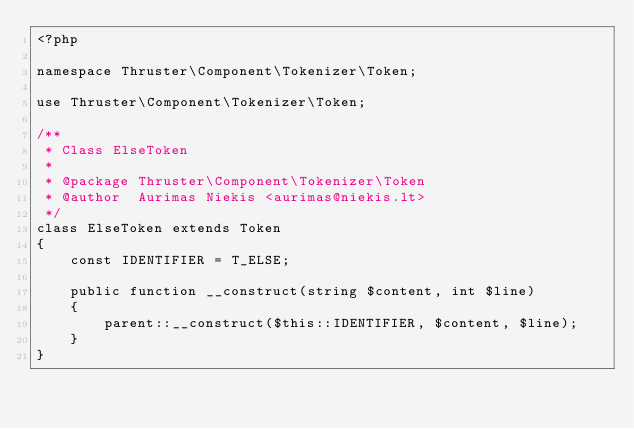Convert code to text. <code><loc_0><loc_0><loc_500><loc_500><_PHP_><?php

namespace Thruster\Component\Tokenizer\Token;

use Thruster\Component\Tokenizer\Token;

/**
 * Class ElseToken
 *
 * @package Thruster\Component\Tokenizer\Token
 * @author  Aurimas Niekis <aurimas@niekis.lt>
 */
class ElseToken extends Token
{
    const IDENTIFIER = T_ELSE;

    public function __construct(string $content, int $line)
    {
        parent::__construct($this::IDENTIFIER, $content, $line);
    }
}
</code> 